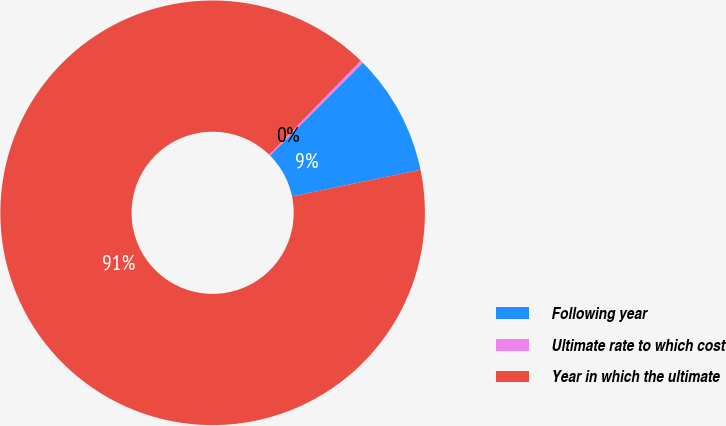Convert chart to OTSL. <chart><loc_0><loc_0><loc_500><loc_500><pie_chart><fcel>Following year<fcel>Ultimate rate to which cost<fcel>Year in which the ultimate<nl><fcel>9.25%<fcel>0.22%<fcel>90.52%<nl></chart> 